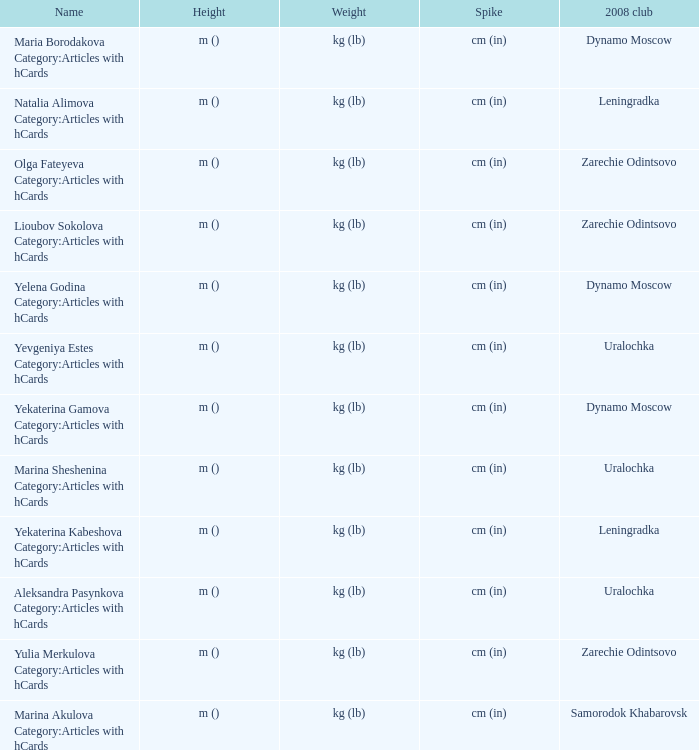In 2008, what was the name of the club known as uralochka? Yevgeniya Estes Category:Articles with hCards, Marina Sheshenina Category:Articles with hCards, Aleksandra Pasynkova Category:Articles with hCards. 